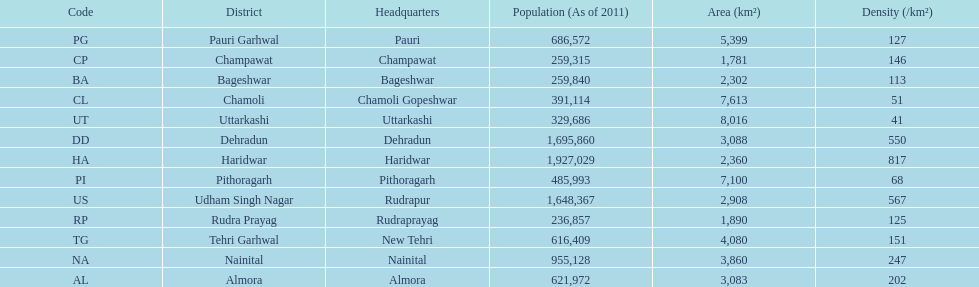If a person was headquartered in almora what would be his/her district? Almora. 